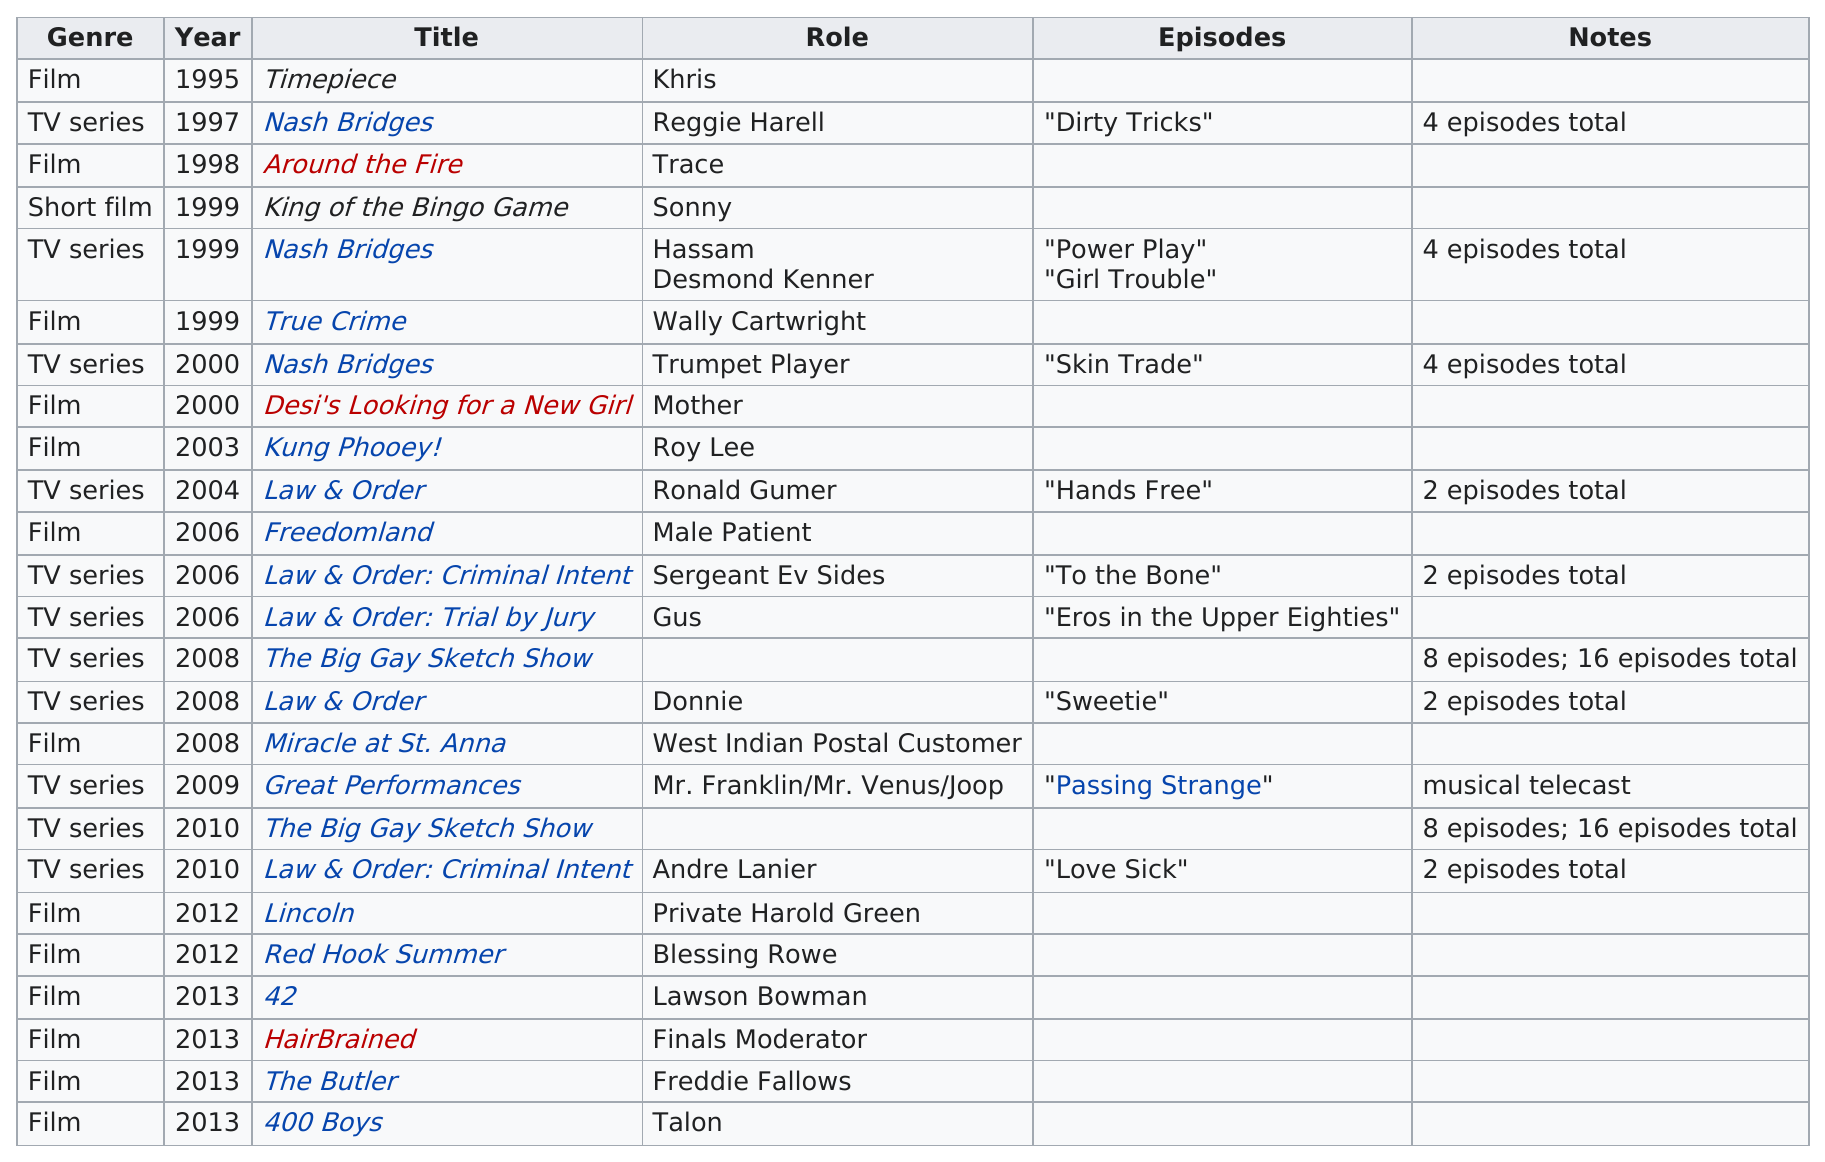Specify some key components in this picture. Coleman Domingo's first TV series was Nash Bridges. In 2013, Domingo appeared in a total of four films. Domingo has appeared in 14 different films. The total amount of films that Colman appeared in 2012 is unknown. There were 16 episodes of "The Big Gay Sketch Show" in total. 